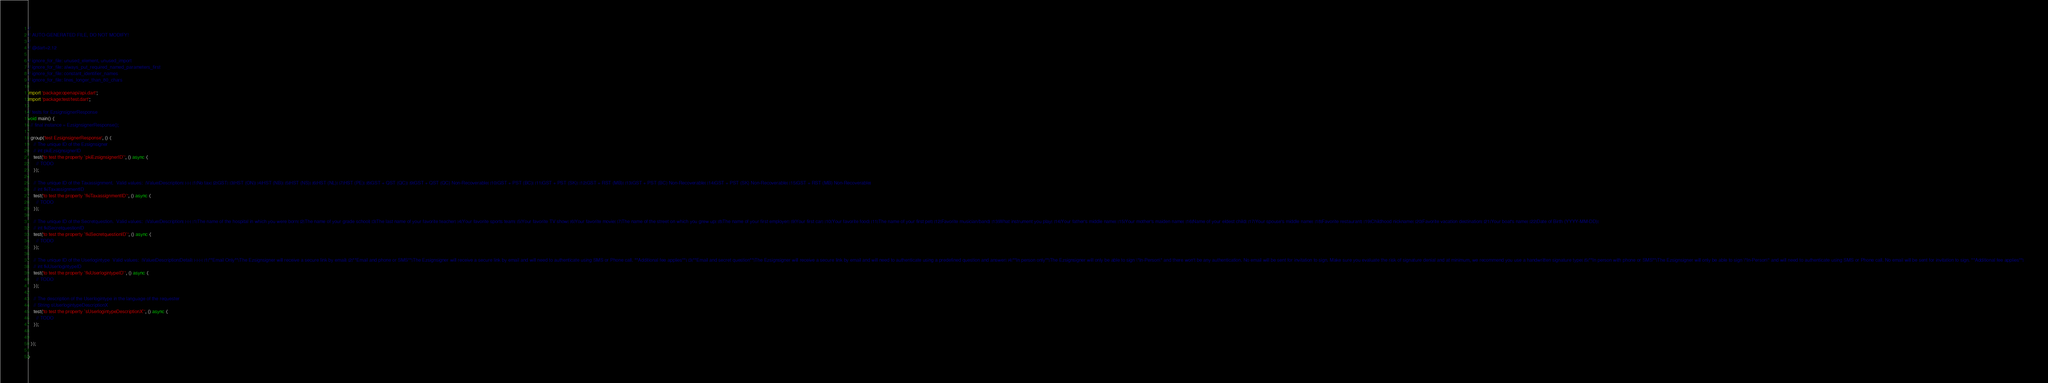<code> <loc_0><loc_0><loc_500><loc_500><_Dart_>//
// AUTO-GENERATED FILE, DO NOT MODIFY!
//
// @dart=2.12

// ignore_for_file: unused_element, unused_import
// ignore_for_file: always_put_required_named_parameters_first
// ignore_for_file: constant_identifier_names
// ignore_for_file: lines_longer_than_80_chars

import 'package:openapi/api.dart';
import 'package:test/test.dart';

// tests for EzsignsignerResponse
void main() {
  // final instance = EzsignsignerResponse();

  group('test EzsignsignerResponse', () {
    // The unique ID of the Ezsignsigner
    // int pkiEzsignsignerID
    test('to test the property `pkiEzsignsignerID`', () async {
      // TODO
    });

    // The unique ID of the Taxassignment.  Valid values:  |Value|Description| |-|-| |1|No tax| |2|GST| |3|HST (ON)| |4|HST (NB)| |5|HST (NS)| |6|HST (NL)| |7|HST (PE)| |8|GST + QST (QC)| |9|GST + QST (QC) Non-Recoverable| |10|GST + PST (BC)| |11|GST + PST (SK)| |12|GST + RST (MB)| |13|GST + PST (BC) Non-Recoverable| |14|GST + PST (SK) Non-Recoverable| |15|GST + RST (MB) Non-Recoverable|
    // int fkiTaxassignmentID
    test('to test the property `fkiTaxassignmentID`', () async {
      // TODO
    });

    // The unique ID of the Secretquestion.  Valid values:  |Value|Description| |-|-| |1|The name of the hospital in which you were born| |2|The name of your grade school| |3|The last name of your favorite teacher| |4|Your favorite sports team| |5|Your favorite TV show| |6|Your favorite movie| |7|The name of the street on which you grew up| |8|The name of your first employer| |9|Your first car| |10|Your favorite food| |11|The name of your first pet| |12|Favorite musician/band| |13|What instrument you play| |14|Your father's middle name| |15|Your mother's maiden name| |16|Name of your eldest child| |17|Your spouse's middle name| |18|Favorite restaurant| |19|Childhood nickname| |20|Favorite vacation destination| |21|Your boat's name| |22|Date of Birth (YYYY-MM-DD)|
    // int fkiSecretquestionID
    test('to test the property `fkiSecretquestionID`', () async {
      // TODO
    });

    // The unique ID of the Userlogintype  Valid values:  |Value|Description|Detail| |-|-|-| |1|**Email Only**|The Ezsignsigner will receive a secure link by email| |2|**Email and phone or SMS**|The Ezsignsigner will receive a secure link by email and will need to authenticate using SMS or Phone call. **Additional fee applies**| |3|**Email and secret question**|The Ezsignsigner will receive a secure link by email and will need to authenticate using a predefined question and answer| |4|**In person only**|The Ezsignsigner will only be able to sign \"In-Person\" and there won't be any authentication. No email will be sent for invitation to sign. Make sure you evaluate the risk of signature denial and at minimum, we recommend you use a handwritten signature type| |5|**In person with phone or SMS**|The Ezsignsigner will only be able to sign \"In-Person\" and will need to authenticate using SMS or Phone call. No email will be sent for invitation to sign. **Additional fee applies**|
    // int fkiUserlogintypeID
    test('to test the property `fkiUserlogintypeID`', () async {
      // TODO
    });

    // The description of the Userlogintype in the language of the requester
    // String sUserlogintypeDescriptionX
    test('to test the property `sUserlogintypeDescriptionX`', () async {
      // TODO
    });


  });

}
</code> 